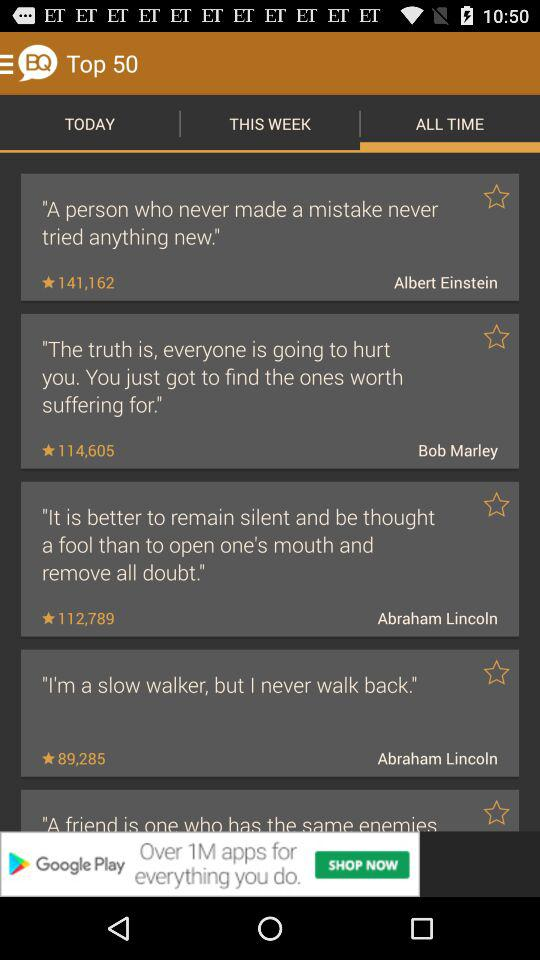What was written by Albert Einstein? Albert Einstein has written "A person who never made a mistake never tried anything new.". 